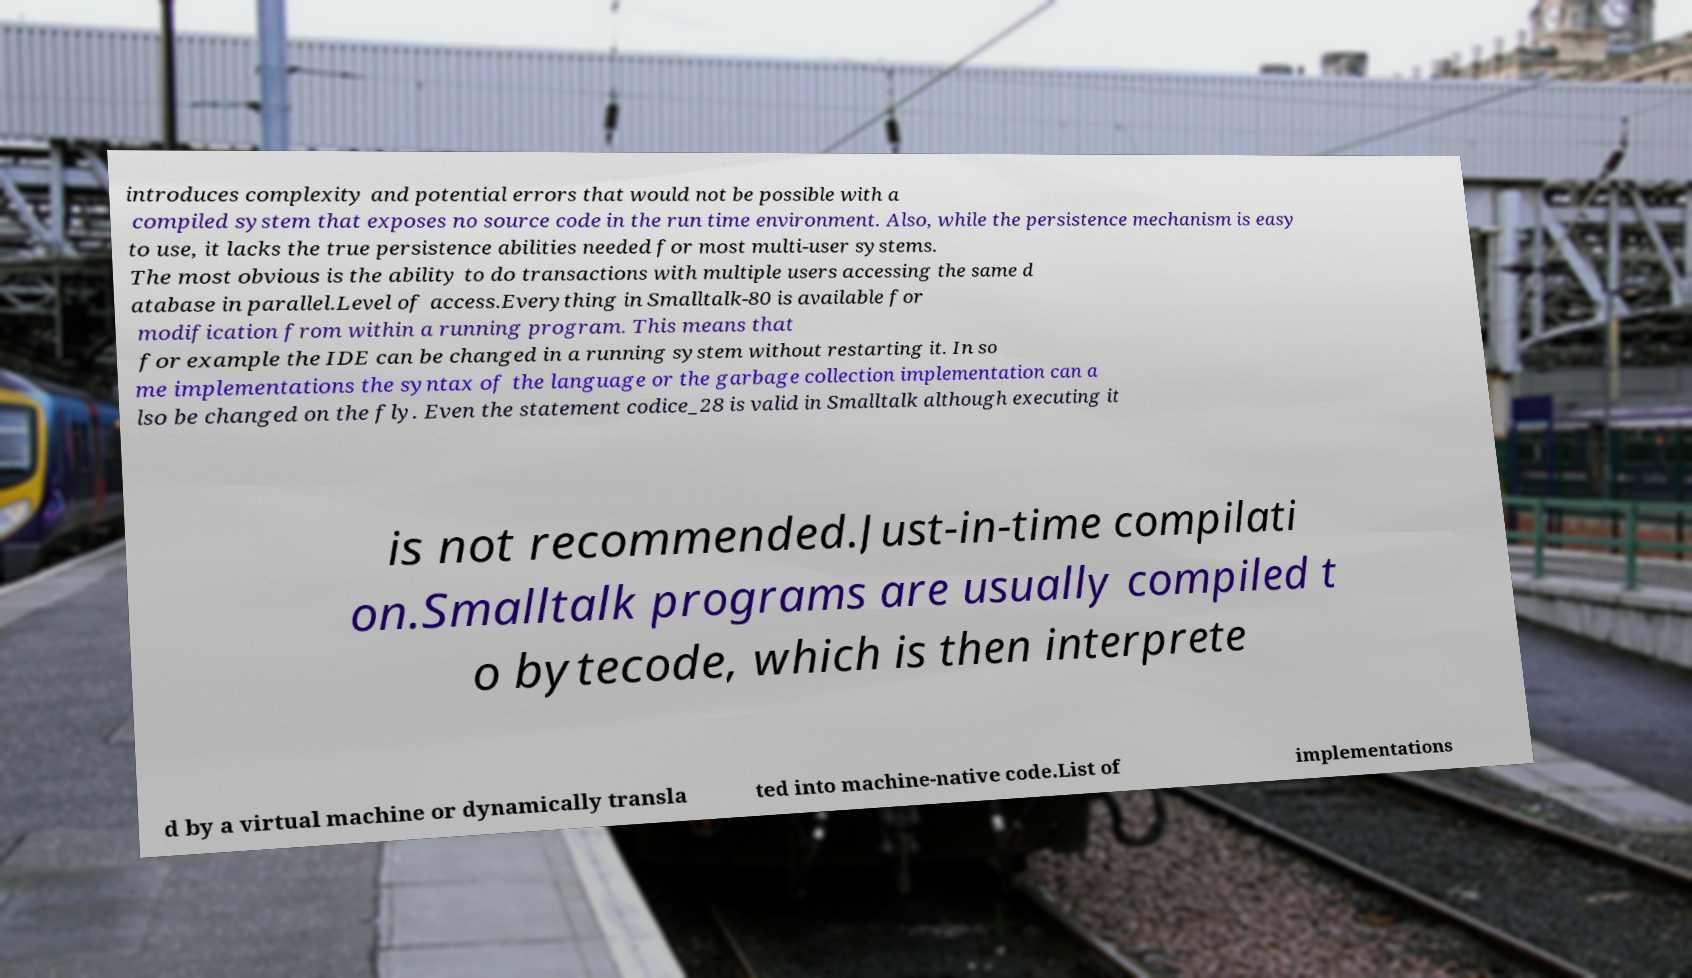I need the written content from this picture converted into text. Can you do that? introduces complexity and potential errors that would not be possible with a compiled system that exposes no source code in the run time environment. Also, while the persistence mechanism is easy to use, it lacks the true persistence abilities needed for most multi-user systems. The most obvious is the ability to do transactions with multiple users accessing the same d atabase in parallel.Level of access.Everything in Smalltalk-80 is available for modification from within a running program. This means that for example the IDE can be changed in a running system without restarting it. In so me implementations the syntax of the language or the garbage collection implementation can a lso be changed on the fly. Even the statement codice_28 is valid in Smalltalk although executing it is not recommended.Just-in-time compilati on.Smalltalk programs are usually compiled t o bytecode, which is then interprete d by a virtual machine or dynamically transla ted into machine-native code.List of implementations 